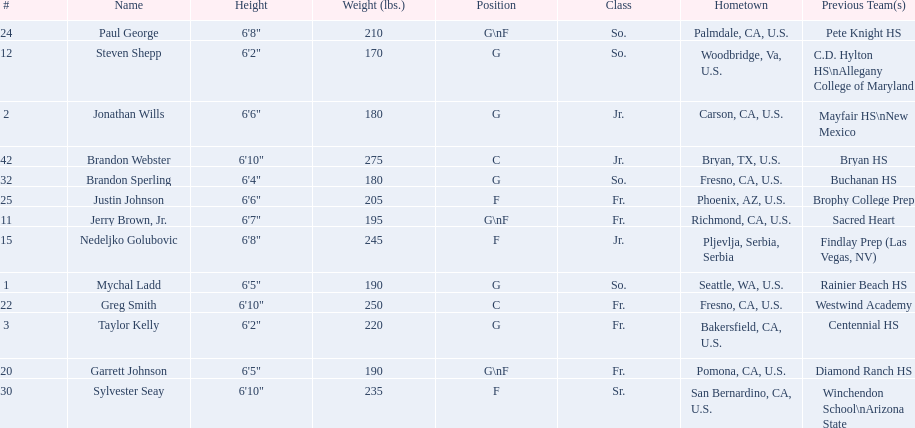What are the listed classes of the players? So., Jr., Fr., Fr., So., Jr., Fr., Fr., So., Fr., Sr., So., Jr. Which of these is not from the us? Jr. To which name does that entry correspond to? Nedeljko Golubovic. 